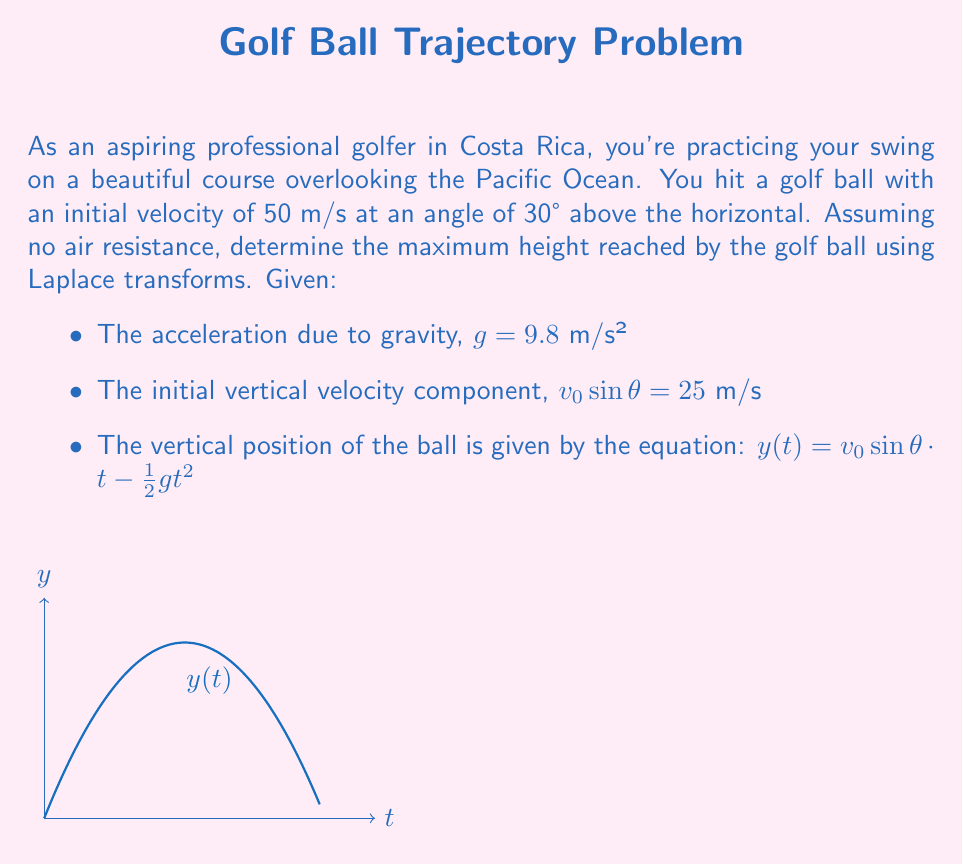Provide a solution to this math problem. Let's approach this problem step-by-step using Laplace transforms:

1) First, we need to take the Laplace transform of the equation for $y(t)$:

   $\mathcal{L}\{y(t)\} = \mathcal{L}\{v_0\sin\theta \cdot t - \frac{1}{2}gt^2\}$

2) Using the linearity property and the Laplace transform of $t$ and $t^2$:

   $Y(s) = v_0\sin\theta \cdot \frac{1}{s^2} - \frac{1}{2}g \cdot \frac{2}{s^3}$

3) Substituting the given values:

   $Y(s) = 25 \cdot \frac{1}{s^2} - \frac{1}{2}(9.8) \cdot \frac{2}{s^3}$

4) Simplifying:

   $Y(s) = \frac{25}{s^2} - \frac{9.8}{s^3}$

5) To find the maximum height, we need to find when the velocity is zero. The velocity is the derivative of position with respect to time. In the s-domain, this is equivalent to multiplying by s and subtracting the initial value:

   $V(s) = sY(s) - y(0) = s(\frac{25}{s^2} - \frac{9.8}{s^3}) - 0 = \frac{25}{s} - \frac{9.8}{s^2}$

6) Taking the inverse Laplace transform:

   $v(t) = 25 - 9.8t$

7) Set $v(t) = 0$ to find the time when the ball reaches its maximum height:

   $25 - 9.8t = 0$
   $t = \frac{25}{9.8} \approx 2.55$ seconds

8) Now, substitute this time back into the original equation for $y(t)$:

   $y(2.55) = 25(2.55) - \frac{1}{2}(9.8)(2.55)^2$

9) Calculate:

   $y(2.55) = 63.75 - 31.875 = 31.875$ meters
Answer: $31.875$ meters 